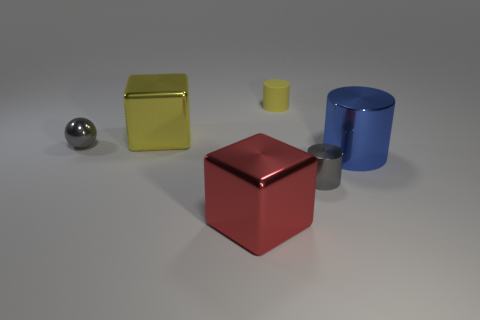What number of other things are made of the same material as the red block?
Keep it short and to the point. 4. There is a blue object that is the same size as the red metallic object; what material is it?
Offer a very short reply. Metal. What number of purple things are either metallic cubes or tiny cylinders?
Offer a very short reply. 0. What color is the object that is right of the tiny rubber cylinder and on the left side of the blue metal cylinder?
Offer a terse response. Gray. Do the big object that is right of the yellow rubber cylinder and the tiny gray thing that is to the left of the large yellow cube have the same material?
Provide a succinct answer. Yes. Is the number of objects behind the ball greater than the number of tiny yellow objects to the right of the small gray cylinder?
Provide a succinct answer. Yes. There is a yellow metallic thing that is the same size as the red metal thing; what shape is it?
Give a very brief answer. Cube. How many things are metallic cylinders or large metal cylinders on the right side of the gray ball?
Provide a short and direct response. 2. Is the color of the matte cylinder the same as the large metal cylinder?
Ensure brevity in your answer.  No. There is a small metal cylinder; how many matte things are right of it?
Give a very brief answer. 0. 